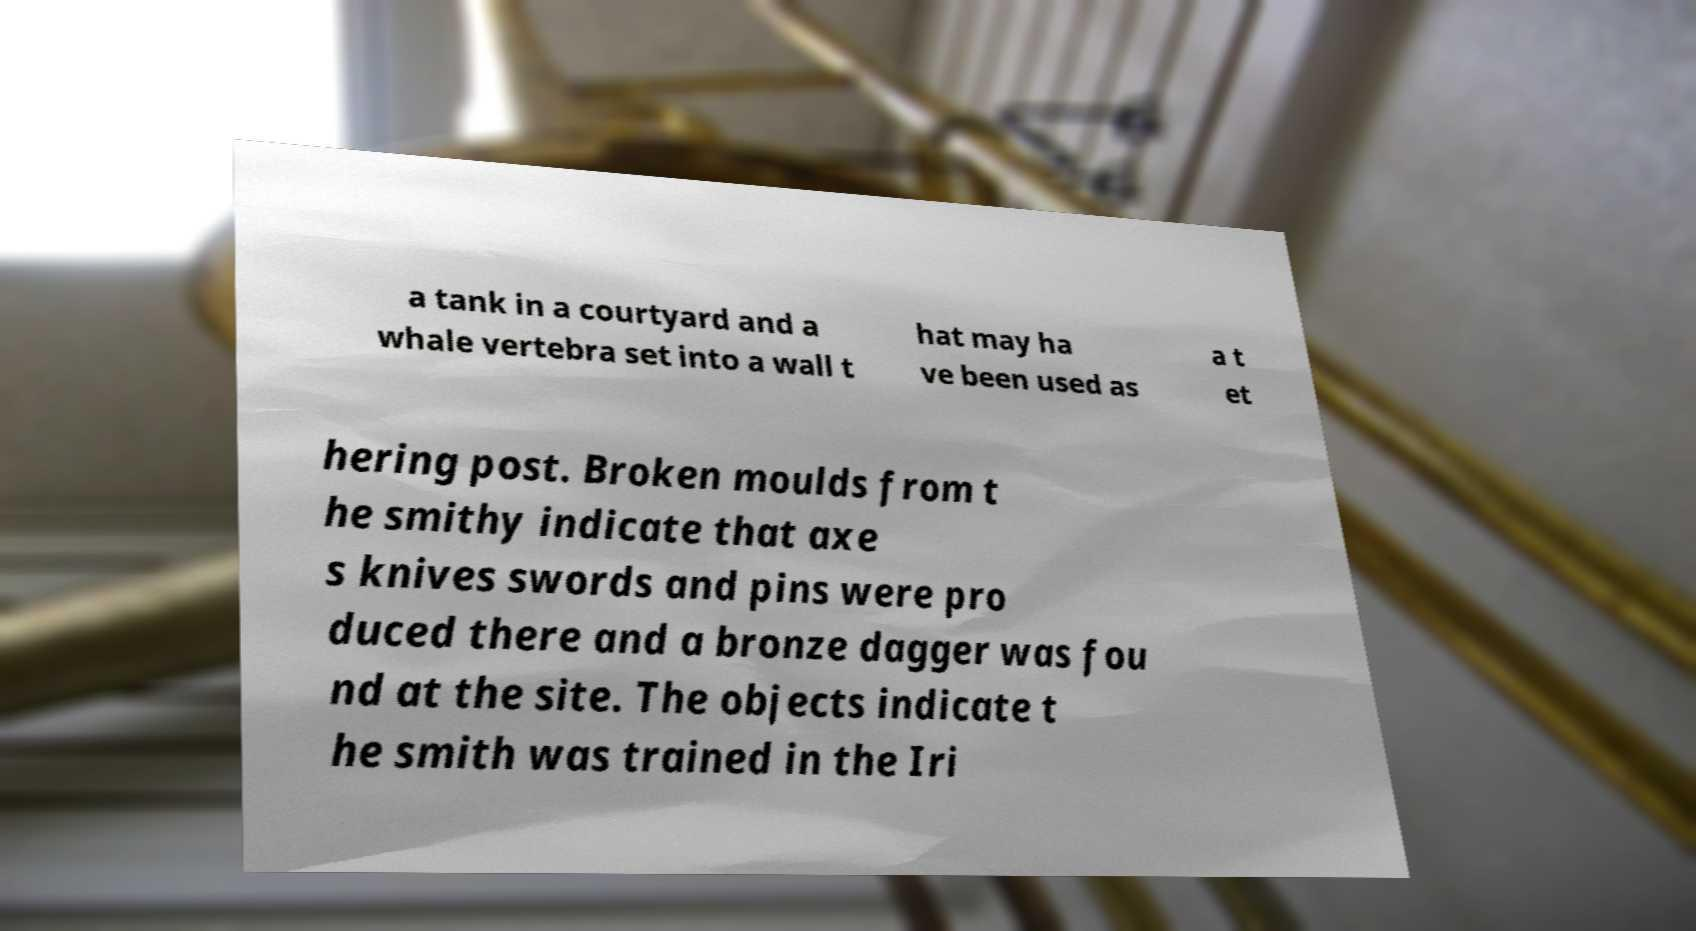Could you extract and type out the text from this image? a tank in a courtyard and a whale vertebra set into a wall t hat may ha ve been used as a t et hering post. Broken moulds from t he smithy indicate that axe s knives swords and pins were pro duced there and a bronze dagger was fou nd at the site. The objects indicate t he smith was trained in the Iri 